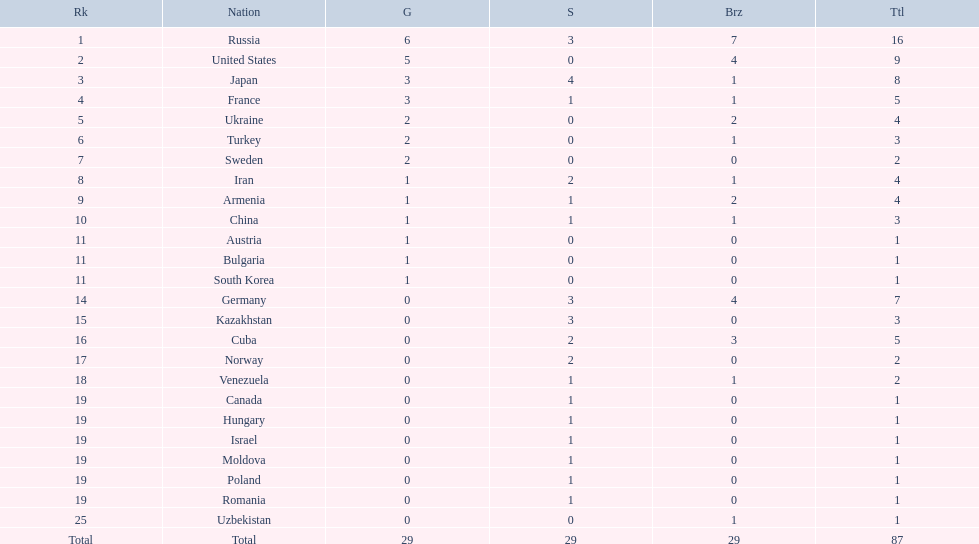Which nations are there? Russia, 6, United States, 5, Japan, 3, France, 3, Ukraine, 2, Turkey, 2, Sweden, 2, Iran, 1, Armenia, 1, China, 1, Austria, 1, Bulgaria, 1, South Korea, 1, Germany, 0, Kazakhstan, 0, Cuba, 0, Norway, 0, Venezuela, 0, Canada, 0, Hungary, 0, Israel, 0, Moldova, 0, Poland, 0, Romania, 0, Uzbekistan, 0. Which nations won gold? Russia, 6, United States, 5, Japan, 3, France, 3, Ukraine, 2, Turkey, 2, Sweden, 2, Iran, 1, Armenia, 1, China, 1, Austria, 1, Bulgaria, 1, South Korea, 1. How many golds did united states win? United States, 5. Which country has more than 5 gold medals? Russia, 6. What country is it? Russia. 